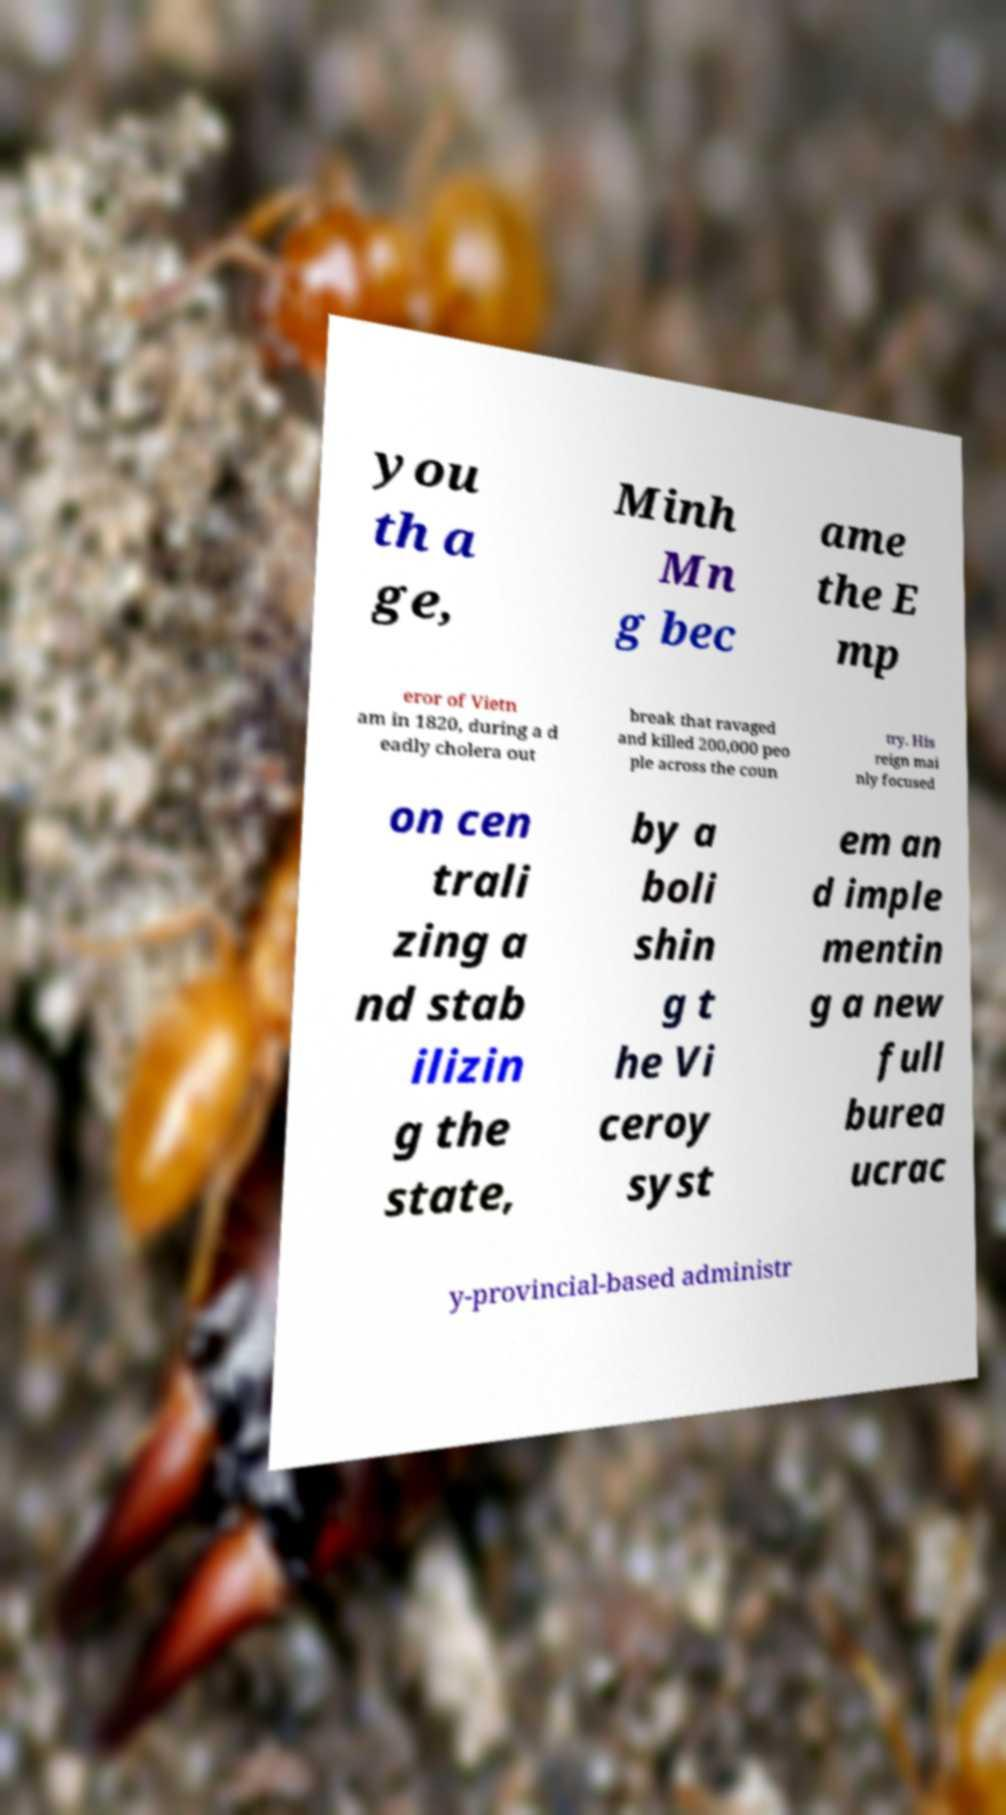Please identify and transcribe the text found in this image. you th a ge, Minh Mn g bec ame the E mp eror of Vietn am in 1820, during a d eadly cholera out break that ravaged and killed 200,000 peo ple across the coun try. His reign mai nly focused on cen trali zing a nd stab ilizin g the state, by a boli shin g t he Vi ceroy syst em an d imple mentin g a new full burea ucrac y-provincial-based administr 